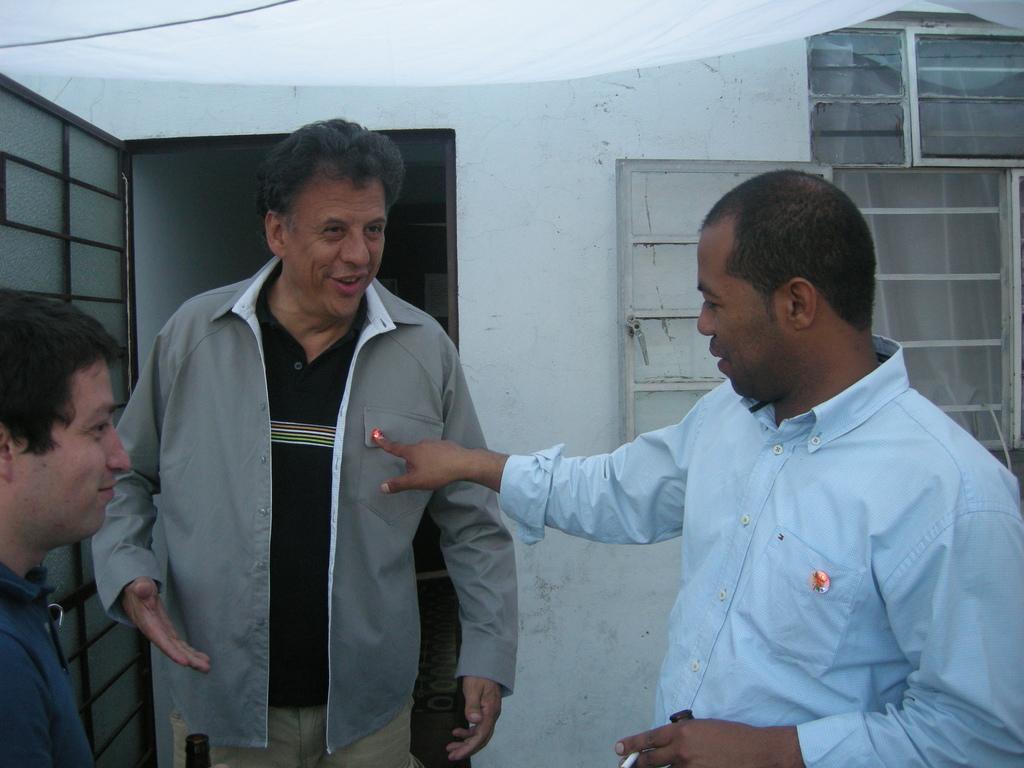Can you describe this image briefly? In the picture I can see three men. I can see a man on the right side wearing a shirt and he is pointing his finger towards a man on the left side. There is a man on the left side wearing a black color T-shirt and shirt as well. There is a smile on his face. I can see the metal grill door on the left side. I can see the glass window on the right side. I can see a white colored cloth at the top of the picture. 